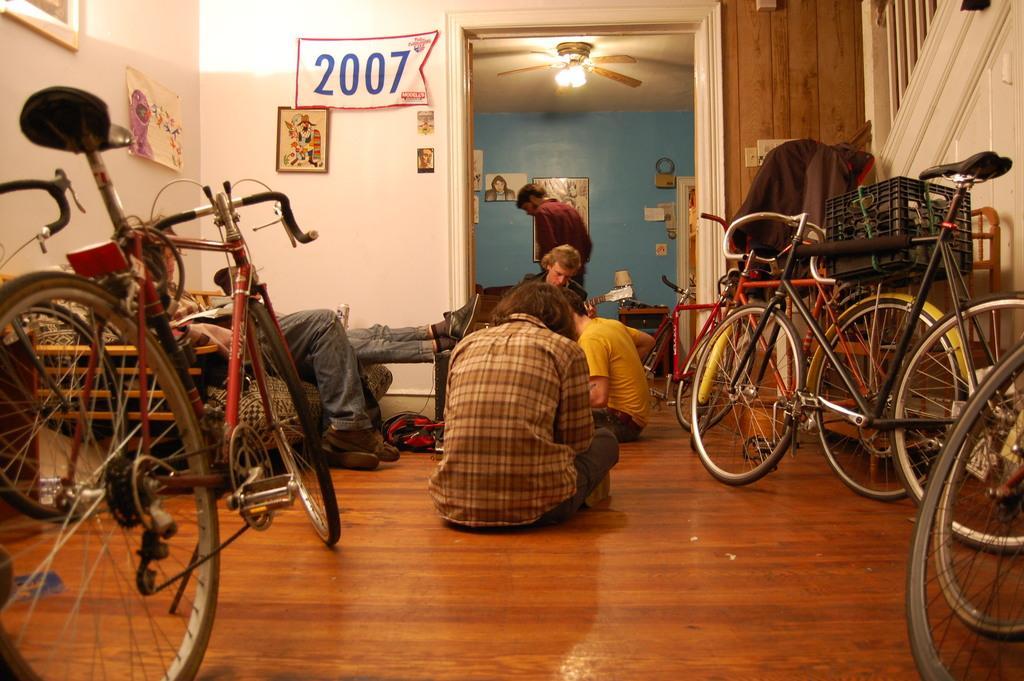In one or two sentences, can you explain what this image depicts? In the background we can see the frames on the wall and a person is standing. At the top we can see the ceiling, lights and a fan. On the left side of the picture we can see the posters and frames on the wall. In this picture we can see the bicycles. We can see the people. Few are resting on the sofa and few are sitting on the floor. On the right side of the picture it seems like the staircase. In this picture we can see few objects. 